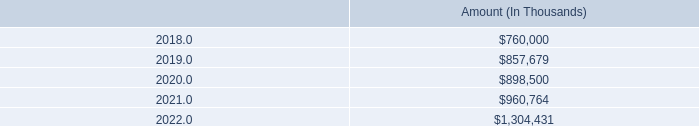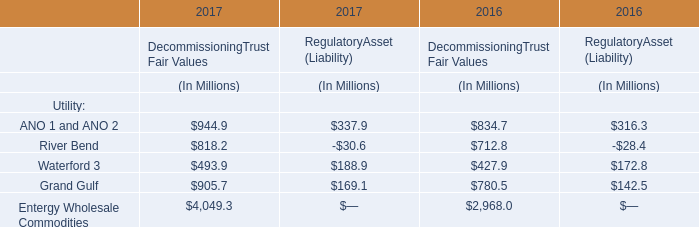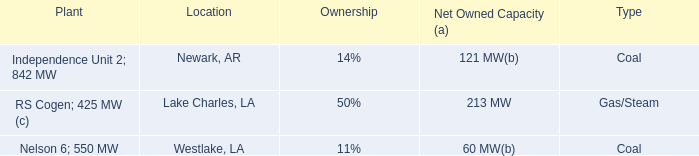What's the greatest value of ANO 1 and ANO 2 in 2017? (in Million) 
Computations: (944.9 + 337.9)
Answer: 1282.8. 